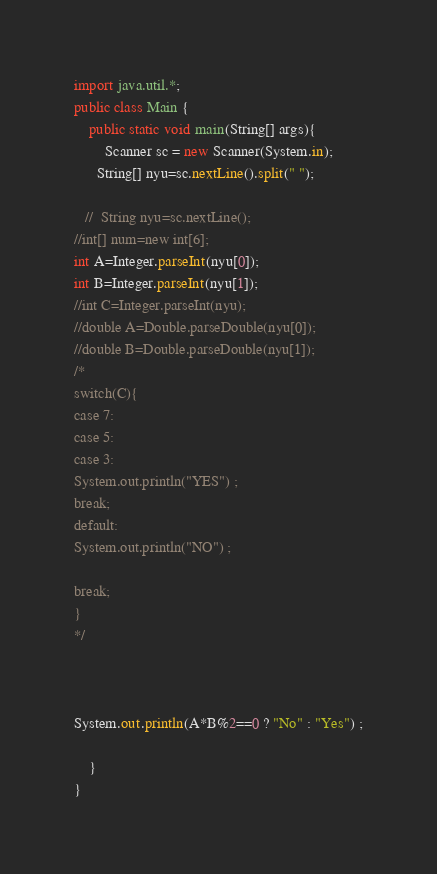<code> <loc_0><loc_0><loc_500><loc_500><_Java_>
import java.util.*;
public class Main {
	public static void main(String[] args){
		Scanner sc = new Scanner(System.in);
      String[] nyu=sc.nextLine().split(" ");

   //  String nyu=sc.nextLine();
//int[] num=new int[6];
int A=Integer.parseInt(nyu[0]);
int B=Integer.parseInt(nyu[1]);
//int C=Integer.parseInt(nyu);
//double A=Double.parseDouble(nyu[0]);
//double B=Double.parseDouble(nyu[1]);
/*
switch(C){
case 7:
case 5:
case 3:
System.out.println("YES") ;
break;
default:
System.out.println("NO") ;

break;
}
*/



System.out.println(A*B%2==0 ? "No" : "Yes") ;

	}
}</code> 